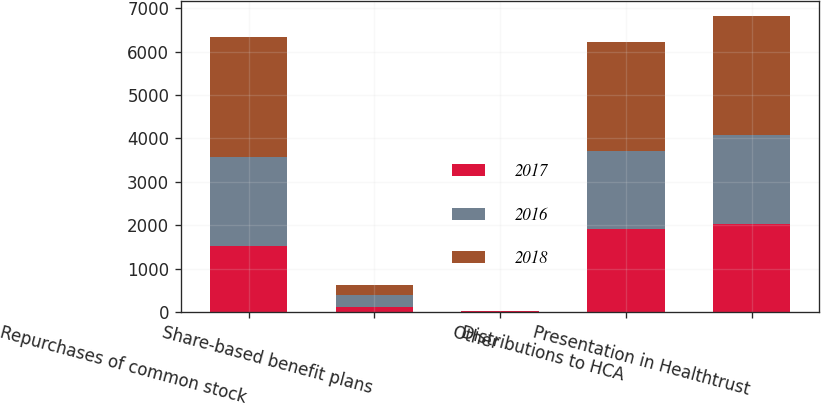Convert chart. <chart><loc_0><loc_0><loc_500><loc_500><stacked_bar_chart><ecel><fcel>Repurchases of common stock<fcel>Share-based benefit plans<fcel>Other<fcel>Distributions to HCA<fcel>Presentation in Healthtrust<nl><fcel>2017<fcel>1530<fcel>115<fcel>12<fcel>1923<fcel>2017<nl><fcel>2016<fcel>2051<fcel>281<fcel>10<fcel>1780<fcel>2051<nl><fcel>2018<fcel>2751<fcel>233<fcel>2<fcel>2520<fcel>2751<nl></chart> 